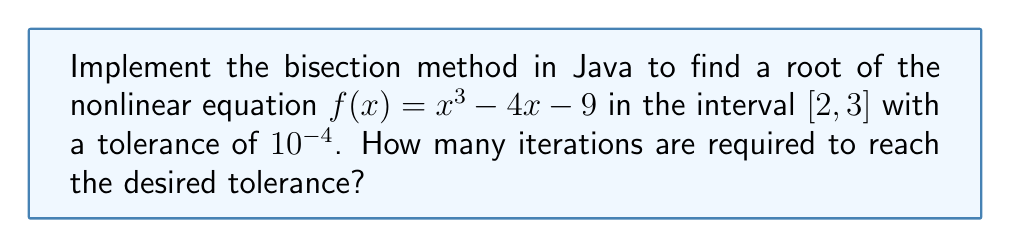What is the answer to this math problem? To solve this problem using the bisection method in Java, we'll follow these steps:

1. Define the function $f(x) = x^3 - 4x - 9$
2. Set the initial interval $[a, b] = [2, 3]$
3. Set the tolerance $\epsilon = 10^{-4}$
4. Implement the bisection method:

   a. Calculate the midpoint: $c = \frac{a + b}{2}$
   b. Evaluate $f(c)$
   c. If $|f(c)| < \epsilon$ or $(b - a) < \epsilon$, stop
   d. If $f(a) \cdot f(c) < 0$, set $b = c$; otherwise, set $a = c$
   e. Increment the iteration counter
   f. Repeat steps a-e

5. Count the number of iterations

Java implementation:

```java
public class BisectionMethod {
    private static final double EPSILON = 1e-4;

    private static double f(double x) {
        return Math.pow(x, 3) - 4 * x - 9;
    }

    public static int bisection(double a, double b) {
        int iterations = 0;
        double c;

        while ((b - a) >= EPSILON) {
            c = (a + b) / 2;
            iterations++;

            if (Math.abs(f(c)) < EPSILON) {
                break;
            }

            if (f(a) * f(c) < 0) {
                b = c;
            } else {
                a = c;
            }
        }

        return iterations;
    }

    public static void main(String[] args) {
        int iterations = bisection(2, 3);
        System.out.println("Number of iterations: " + iterations);
    }
}
```

Running this code will output the number of iterations required to reach the desired tolerance.

The bisection method converges linearly, with each iteration roughly halving the interval. The number of iterations required can be estimated using the formula:

$$n \approx \log_2\left(\frac{b - a}{\epsilon}\right)$$

In this case:
$$n \approx \log_2\left(\frac{3 - 2}{10^{-4}}\right) \approx 13.29$$

So we expect about 14 iterations to reach the desired tolerance.
Answer: 14 iterations 